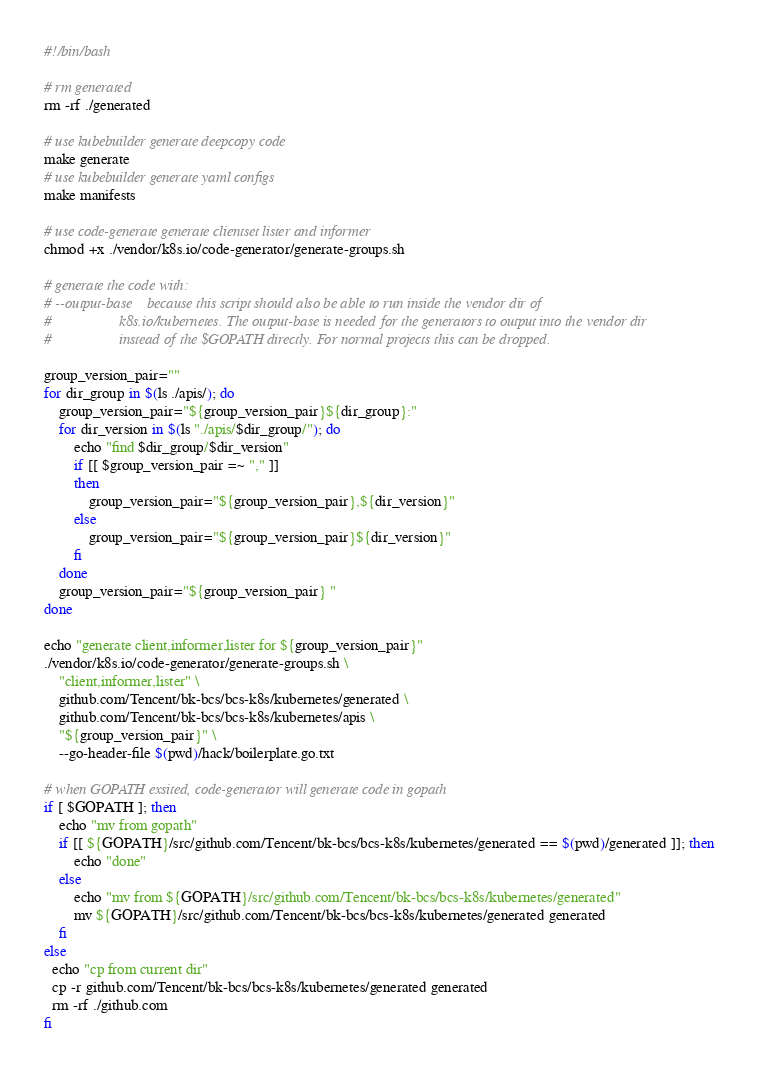<code> <loc_0><loc_0><loc_500><loc_500><_Bash_>#!/bin/bash

# rm generated
rm -rf ./generated

# use kubebuilder generate deepcopy code
make generate
# use kubebuilder generate yaml configs
make manifests

# use code-generate generate clientset lister and informer
chmod +x ./vendor/k8s.io/code-generator/generate-groups.sh

# generate the code with:
# --output-base    because this script should also be able to run inside the vendor dir of
#                  k8s.io/kubernetes. The output-base is needed for the generators to output into the vendor dir
#                  instead of the $GOPATH directly. For normal projects this can be dropped.

group_version_pair=""
for dir_group in $(ls ./apis/); do
    group_version_pair="${group_version_pair}${dir_group}:"
    for dir_version in $(ls "./apis/$dir_group/"); do
        echo "find $dir_group/$dir_version"
        if [[ $group_version_pair =~ "," ]]
        then
            group_version_pair="${group_version_pair},${dir_version}"
        else
            group_version_pair="${group_version_pair}${dir_version}"
        fi
    done
    group_version_pair="${group_version_pair} "
done

echo "generate client,informer,lister for ${group_version_pair}"
./vendor/k8s.io/code-generator/generate-groups.sh \
    "client,informer,lister" \
    github.com/Tencent/bk-bcs/bcs-k8s/kubernetes/generated \
    github.com/Tencent/bk-bcs/bcs-k8s/kubernetes/apis \
    "${group_version_pair}" \
    --go-header-file $(pwd)/hack/boilerplate.go.txt 

# when GOPATH exsited, code-generator will generate code in gopath
if [ $GOPATH ]; then
    echo "mv from gopath"
    if [[ ${GOPATH}/src/github.com/Tencent/bk-bcs/bcs-k8s/kubernetes/generated == $(pwd)/generated ]]; then
        echo "done"
    else
        echo "mv from ${GOPATH}/src/github.com/Tencent/bk-bcs/bcs-k8s/kubernetes/generated"
        mv ${GOPATH}/src/github.com/Tencent/bk-bcs/bcs-k8s/kubernetes/generated generated
    fi
else
  echo "cp from current dir"
  cp -r github.com/Tencent/bk-bcs/bcs-k8s/kubernetes/generated generated
  rm -rf ./github.com
fi 
</code> 